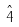<formula> <loc_0><loc_0><loc_500><loc_500>\hat { 4 }</formula> 